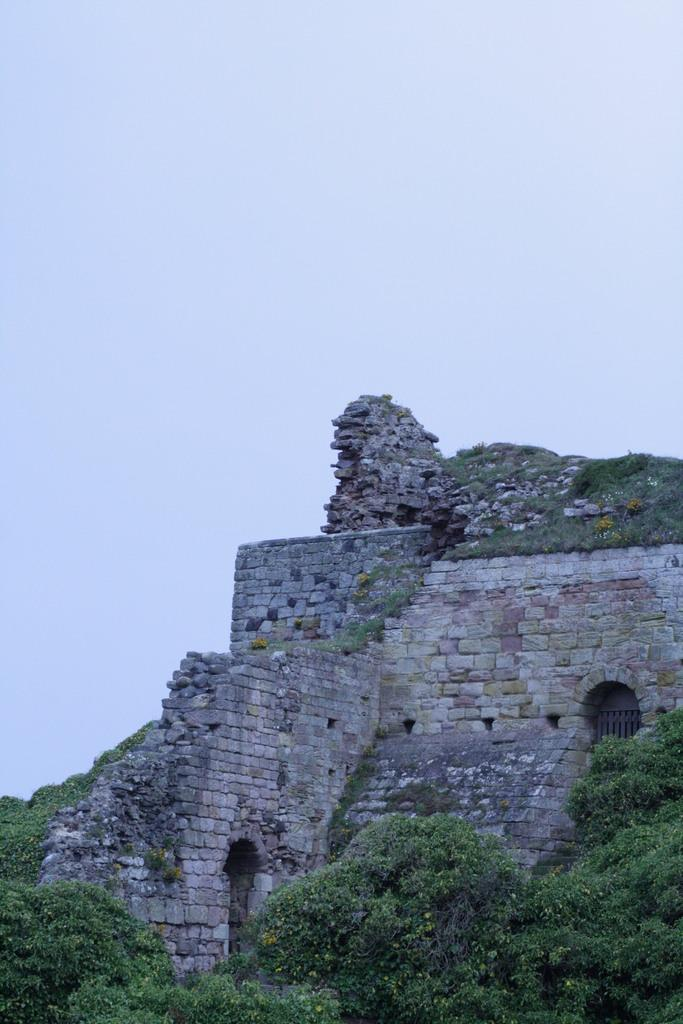What type of structure is present in the image? There is a fort in the image. What type of vegetation can be seen in the image? There are trees in the image. What is the condition of the sky in the image? The sky is clear in the image. Can you see a boy looking at an instrument in the image? There is no boy or instrument present in the image. 